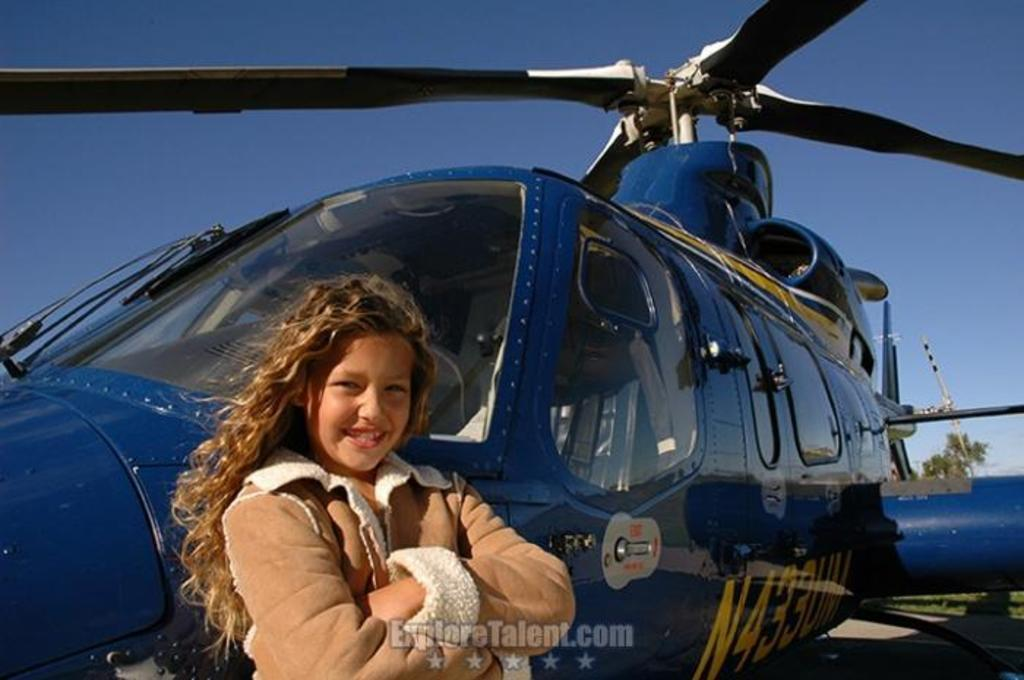<image>
Provide a brief description of the given image. A young girl with long hair and a tan colored winter jacket stands up against a blue helicopter in an ExploreTalent.com ad. 